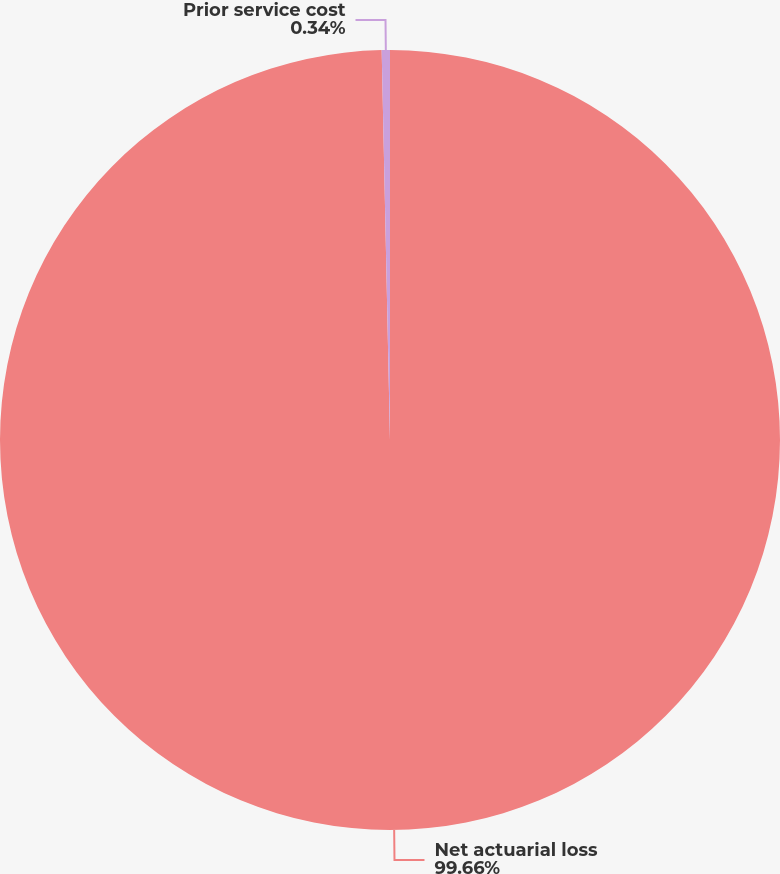Convert chart to OTSL. <chart><loc_0><loc_0><loc_500><loc_500><pie_chart><fcel>Net actuarial loss<fcel>Prior service cost<nl><fcel>99.66%<fcel>0.34%<nl></chart> 